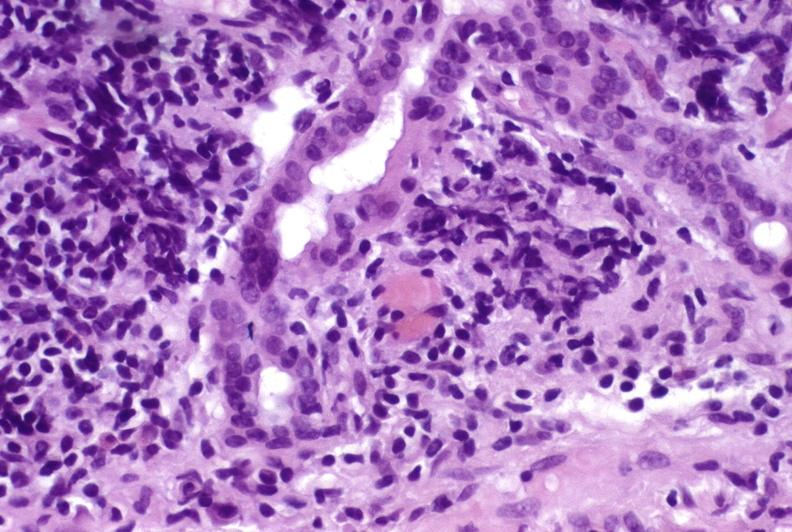does malformed base show recurrent hepatitis c virus?
Answer the question using a single word or phrase. No 